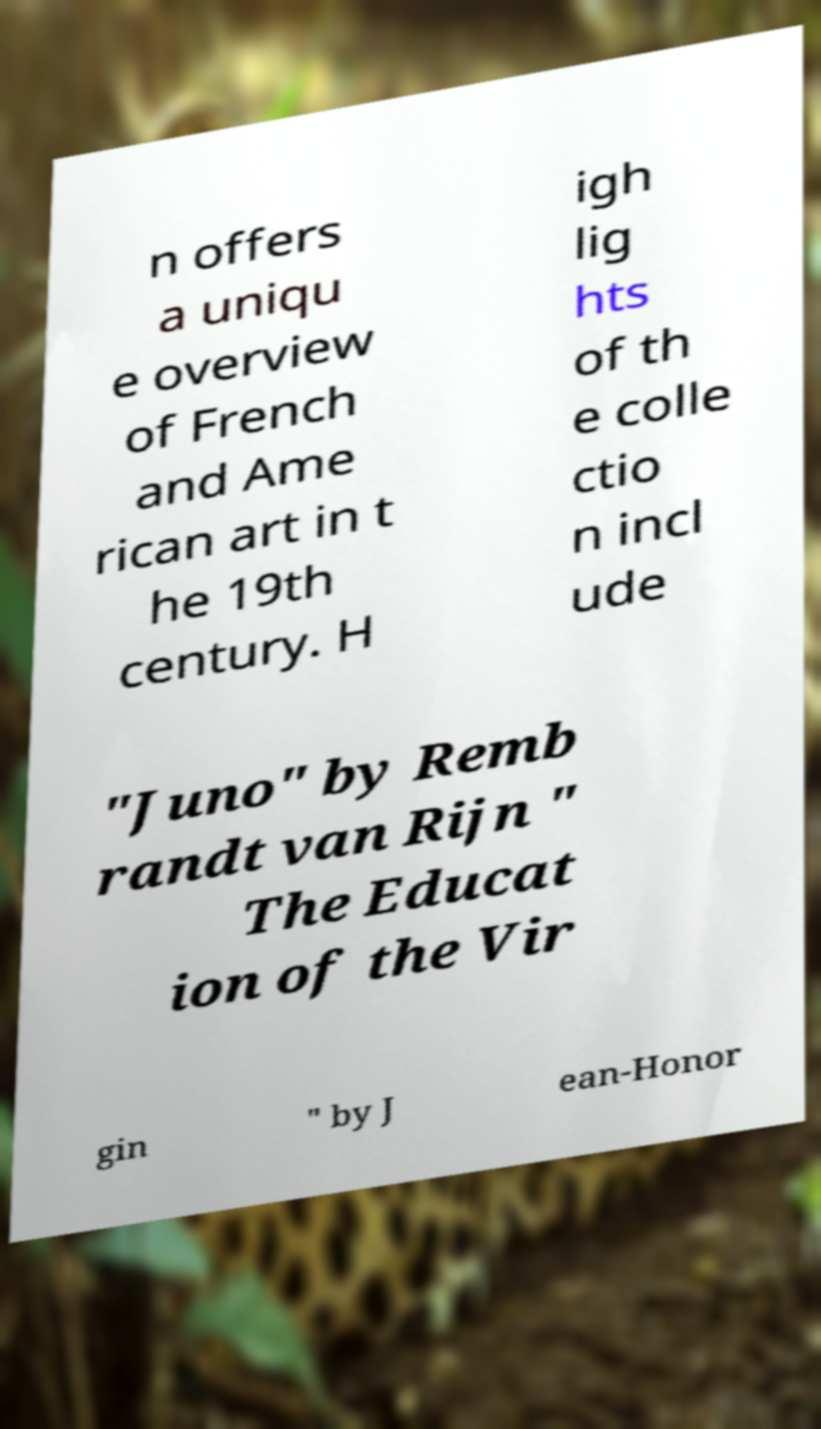Please identify and transcribe the text found in this image. n offers a uniqu e overview of French and Ame rican art in t he 19th century. H igh lig hts of th e colle ctio n incl ude "Juno" by Remb randt van Rijn " The Educat ion of the Vir gin " by J ean-Honor 